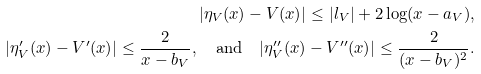Convert formula to latex. <formula><loc_0><loc_0><loc_500><loc_500>| \eta _ { V } ( x ) - V ( x ) | \leq | l _ { V } | + 2 \log ( x - a _ { V } ) , \\ | \eta _ { V } ^ { \prime } ( x ) - V ^ { \prime } ( x ) | \leq \frac { 2 } { x - b _ { V } } , \quad \text {and} \quad | \eta _ { V } ^ { \prime \prime } ( x ) - V ^ { \prime \prime } ( x ) | \leq \frac { 2 } { ( x - b _ { V } ) ^ { 2 } } .</formula> 